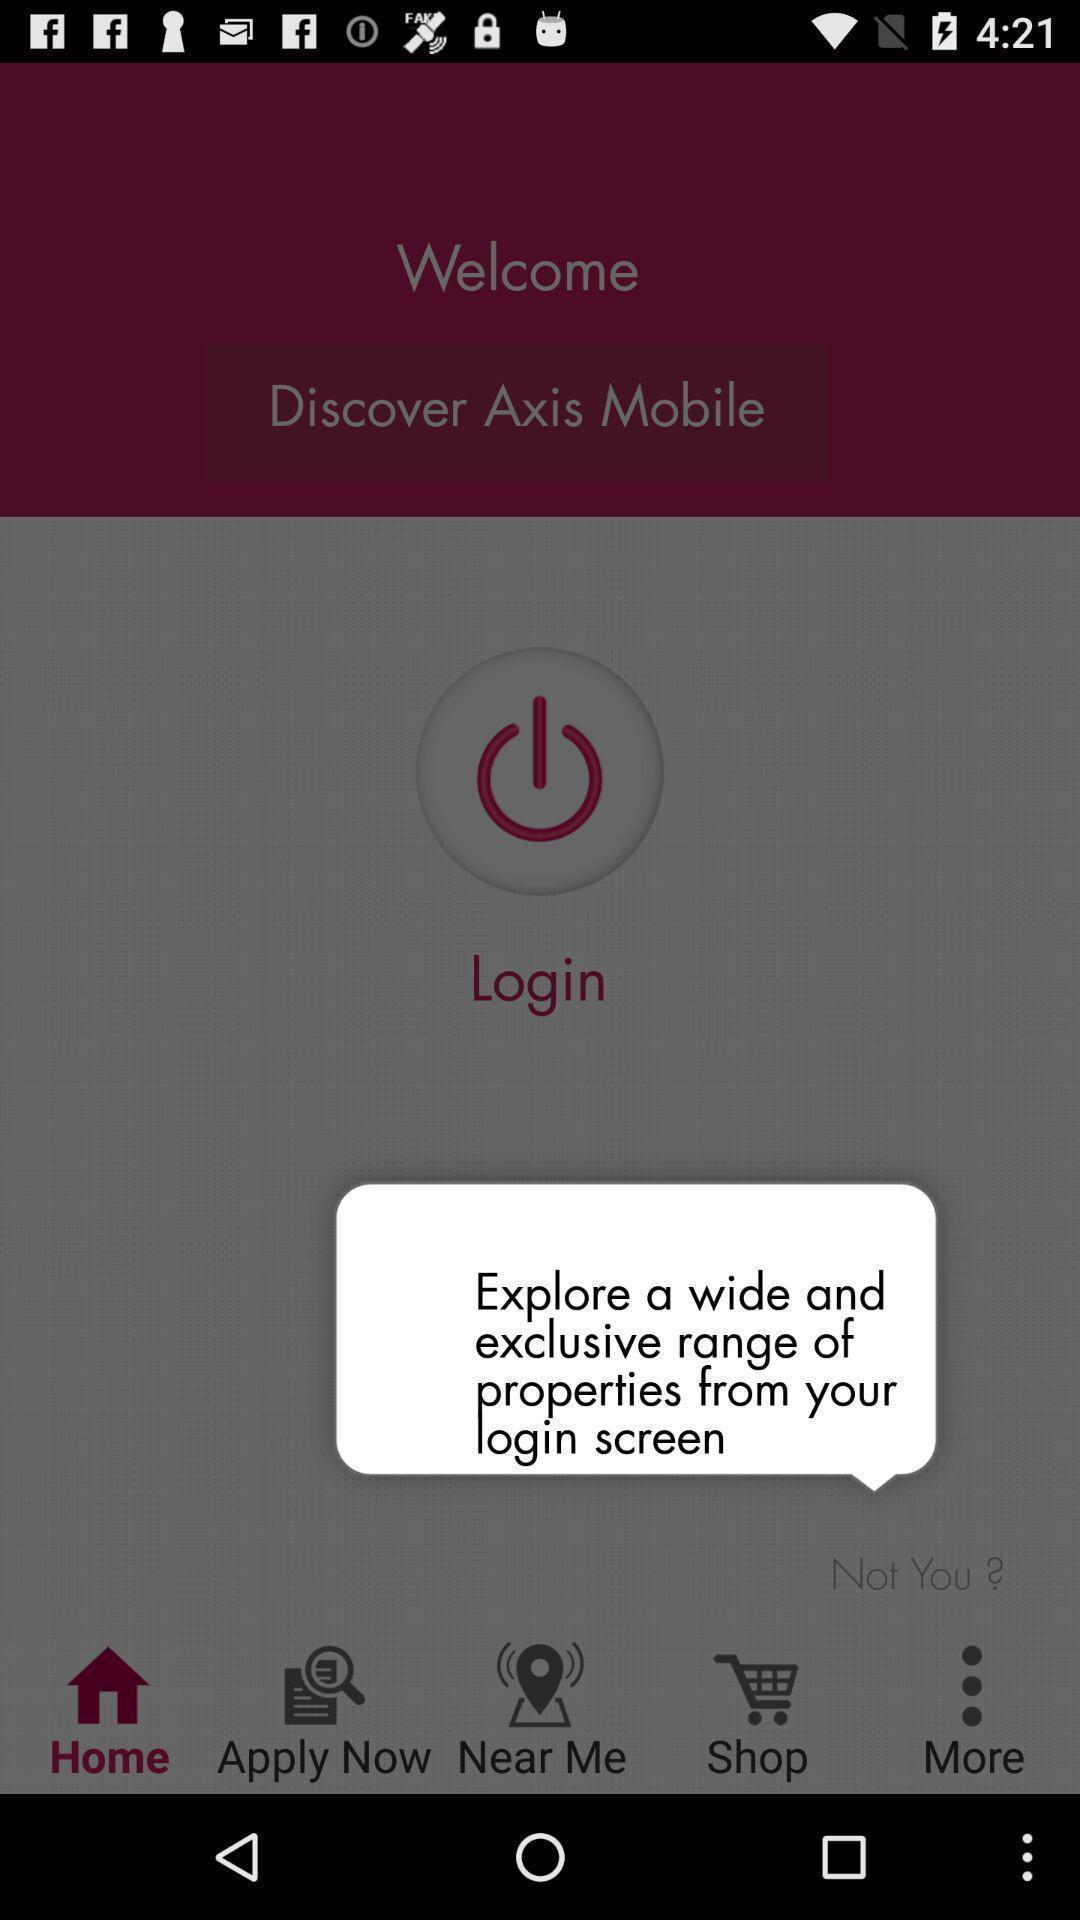What can you discern from this picture? Pop-up shows properties details in a shopping app. 